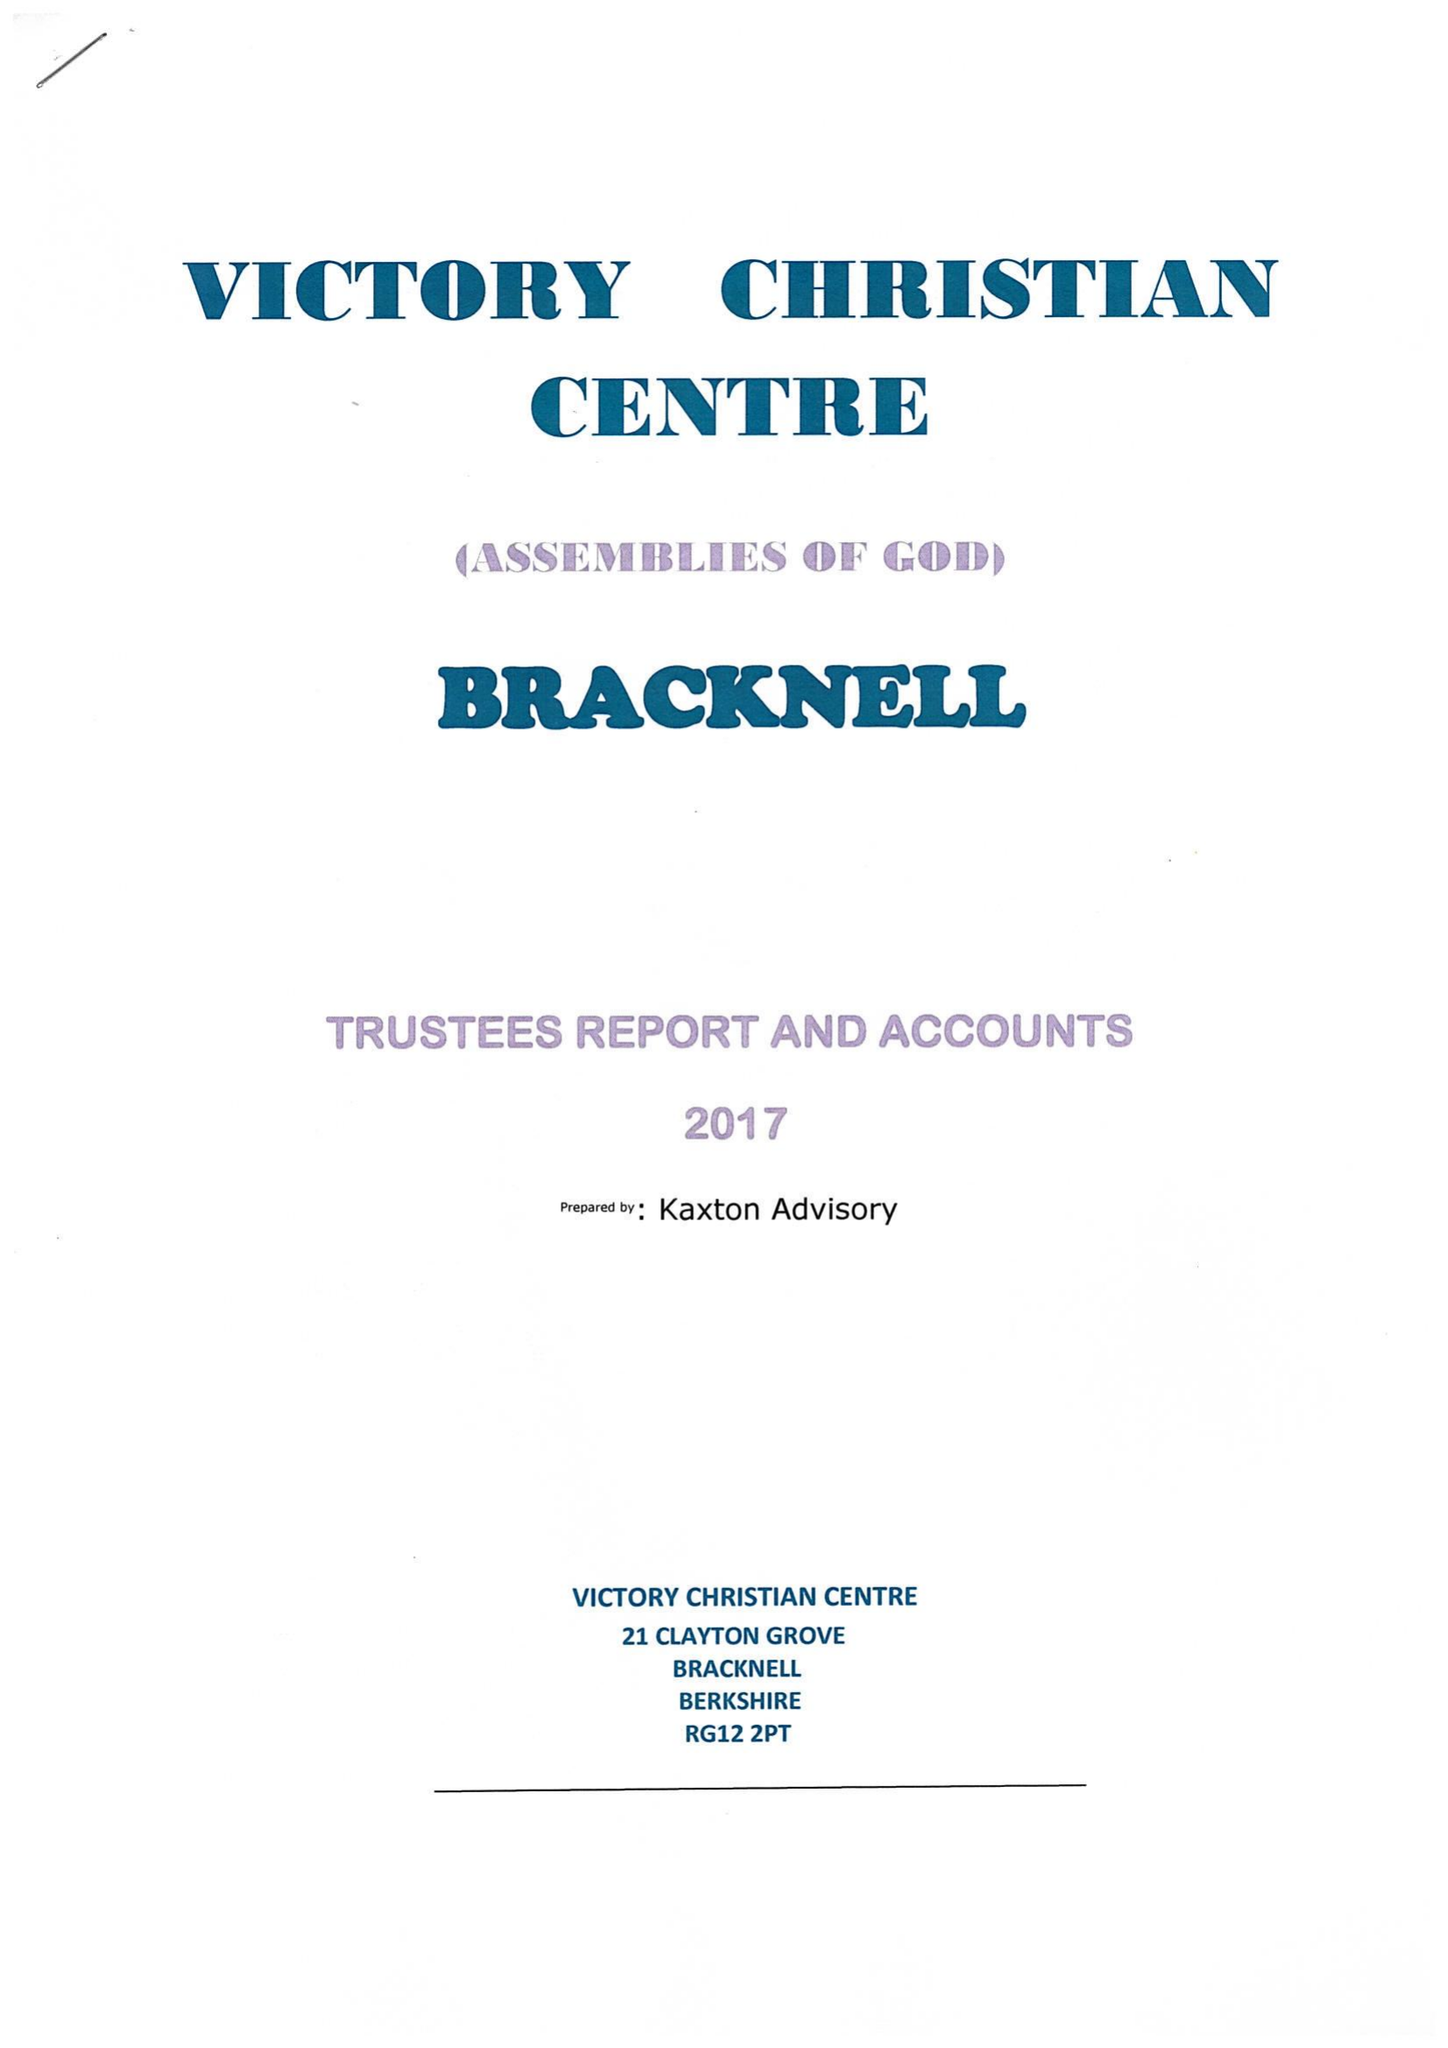What is the value for the address__street_line?
Answer the question using a single word or phrase. 21 CLAYTON GROVE 